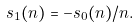Convert formula to latex. <formula><loc_0><loc_0><loc_500><loc_500>s _ { 1 } ( n ) = - s _ { 0 } ( n ) / n .</formula> 